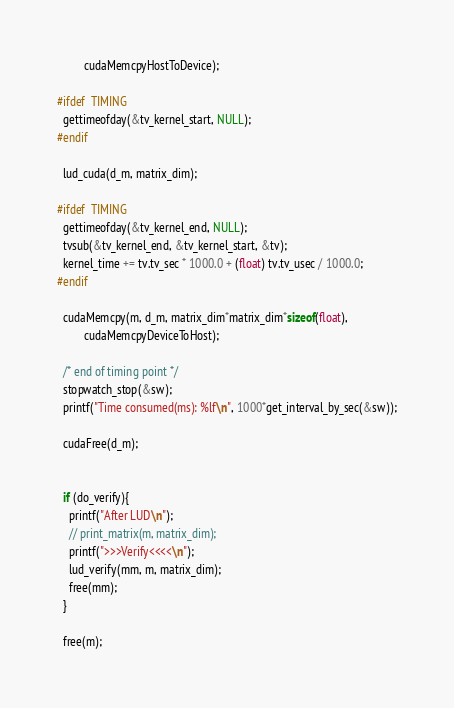Convert code to text. <code><loc_0><loc_0><loc_500><loc_500><_Cuda_>	     cudaMemcpyHostToDevice);

#ifdef  TIMING
  gettimeofday(&tv_kernel_start, NULL);
#endif

  lud_cuda(d_m, matrix_dim);

#ifdef  TIMING
  gettimeofday(&tv_kernel_end, NULL);
  tvsub(&tv_kernel_end, &tv_kernel_start, &tv);
  kernel_time += tv.tv_sec * 1000.0 + (float) tv.tv_usec / 1000.0;
#endif

  cudaMemcpy(m, d_m, matrix_dim*matrix_dim*sizeof(float), 
	     cudaMemcpyDeviceToHost);

  /* end of timing point */
  stopwatch_stop(&sw);
  printf("Time consumed(ms): %lf\n", 1000*get_interval_by_sec(&sw));

  cudaFree(d_m);


  if (do_verify){
    printf("After LUD\n");
    // print_matrix(m, matrix_dim);
    printf(">>>Verify<<<<\n");
    lud_verify(mm, m, matrix_dim); 
    free(mm);
  }

  free(m);
</code> 